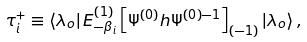Convert formula to latex. <formula><loc_0><loc_0><loc_500><loc_500>\tau _ { i } ^ { + } \equiv \left \langle \lambda _ { o } \right | E _ { - \beta _ { i } } ^ { \left ( 1 \right ) } \left [ { \Psi } ^ { \left ( 0 \right ) } h { \Psi } ^ { \left ( 0 \right ) - 1 } \right ] _ { \left ( - 1 \right ) } \left | \lambda _ { o } \right \rangle ,</formula> 